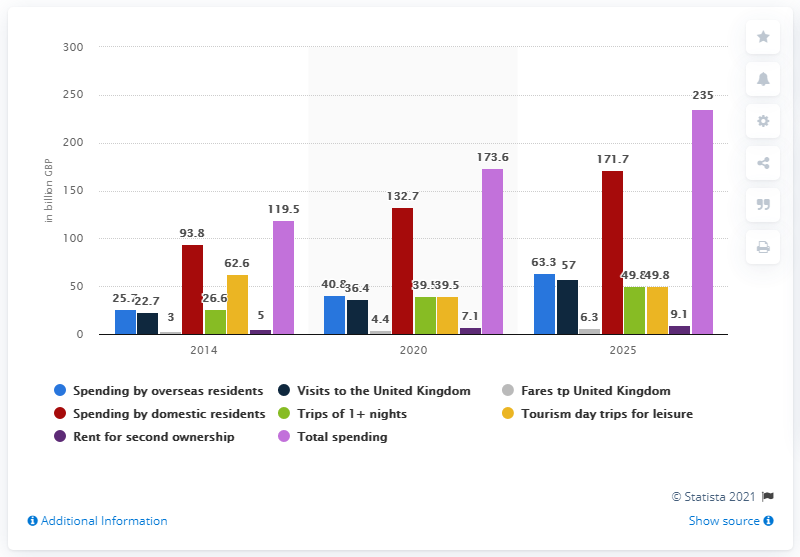What does the purple bar representing 'Trips of 1+ nights' in 2020 tell us? The purple bar in the graph for 2020, indicating 'Trips of 1+ nights', shows spending of 39.1 billion GBP. This represents a notable component of the tourism sector, emphasizing the substantial income generated from multi-night stays by visitors. 